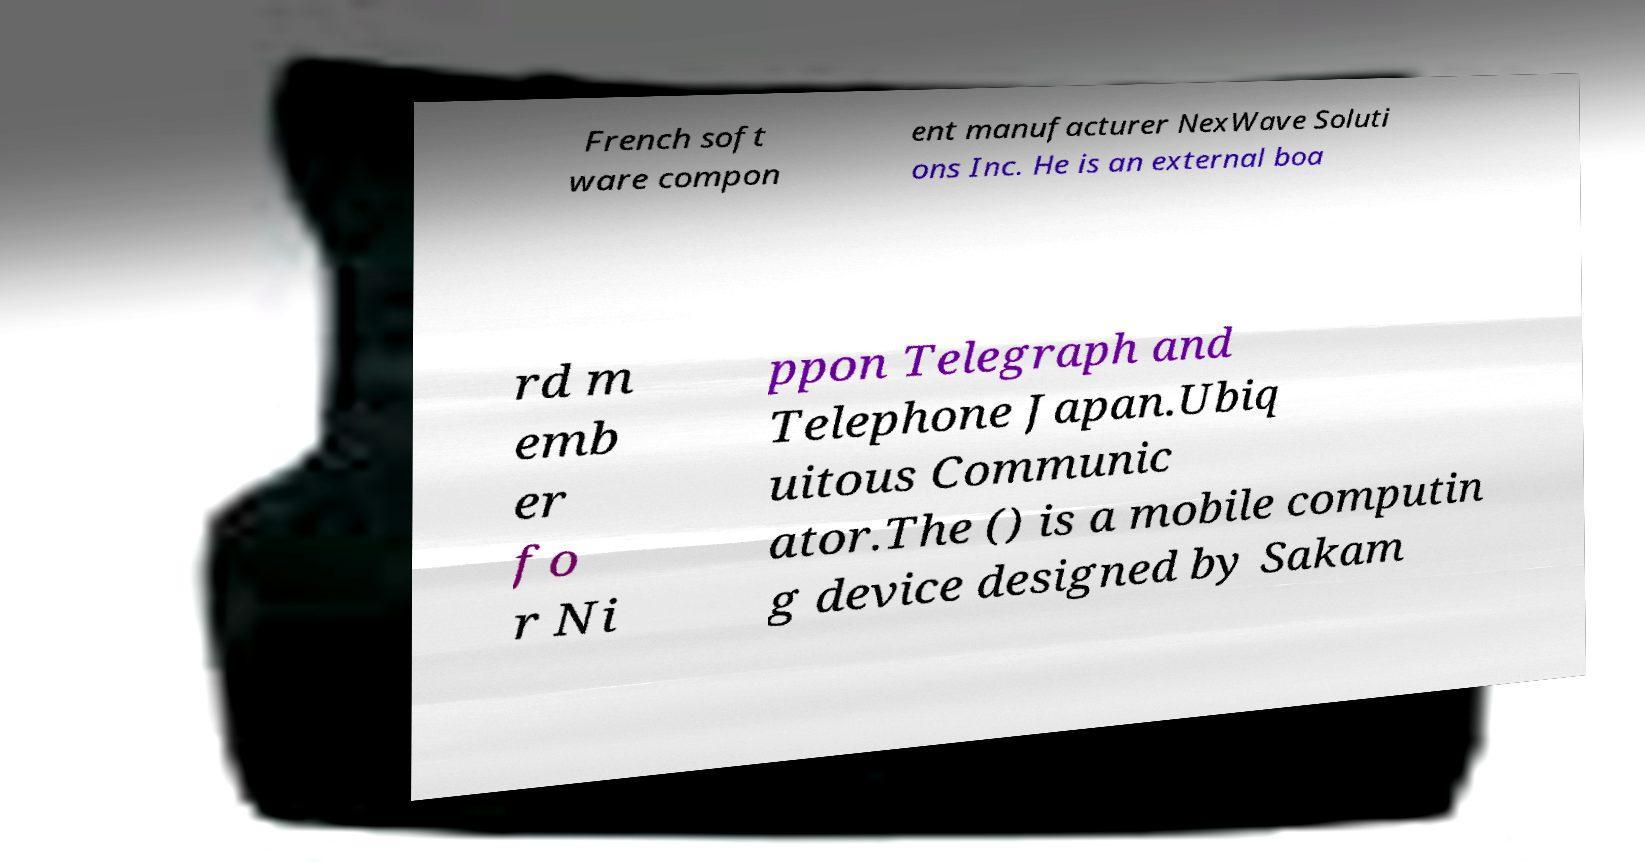Please identify and transcribe the text found in this image. French soft ware compon ent manufacturer NexWave Soluti ons Inc. He is an external boa rd m emb er fo r Ni ppon Telegraph and Telephone Japan.Ubiq uitous Communic ator.The () is a mobile computin g device designed by Sakam 